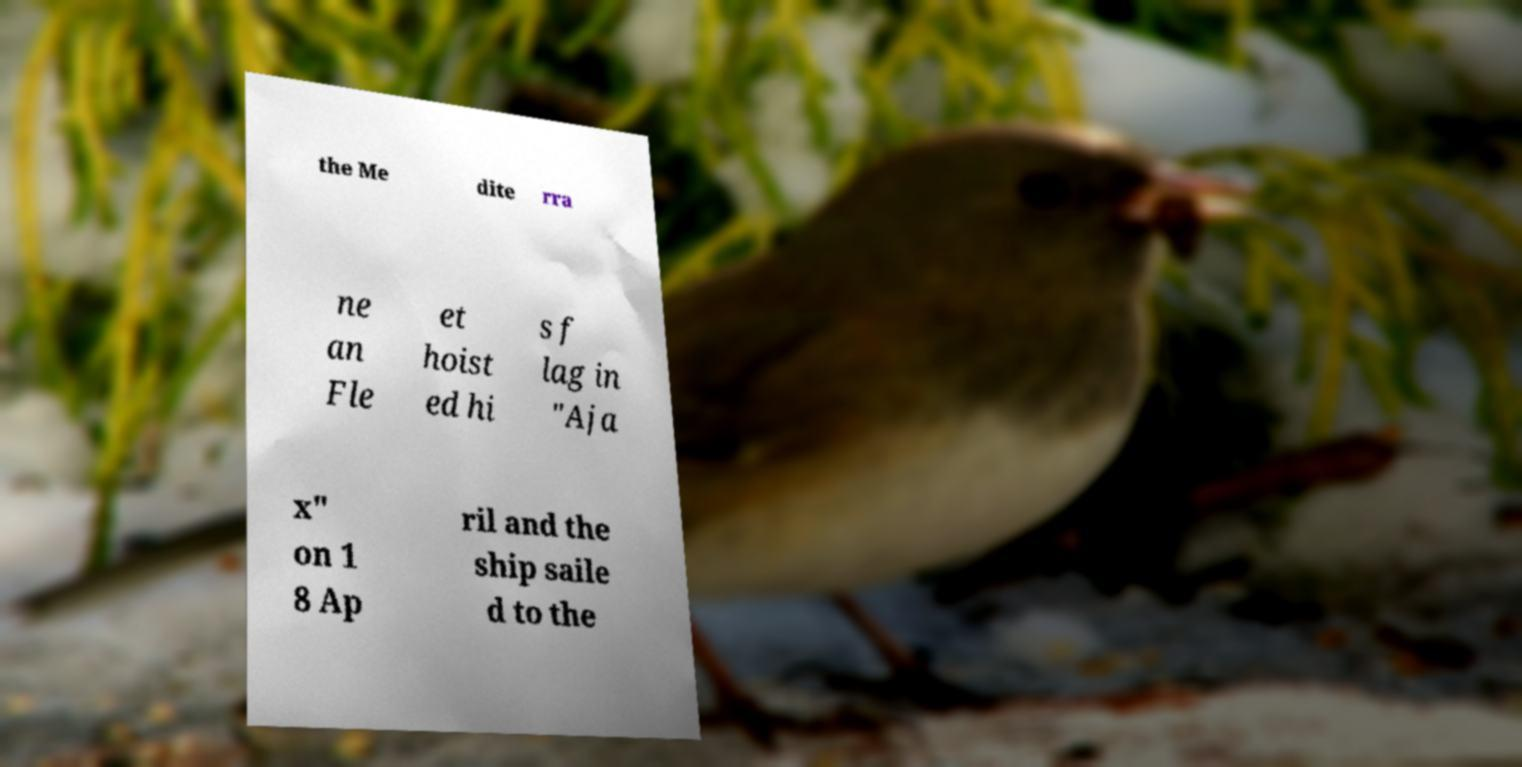For documentation purposes, I need the text within this image transcribed. Could you provide that? the Me dite rra ne an Fle et hoist ed hi s f lag in "Aja x" on 1 8 Ap ril and the ship saile d to the 